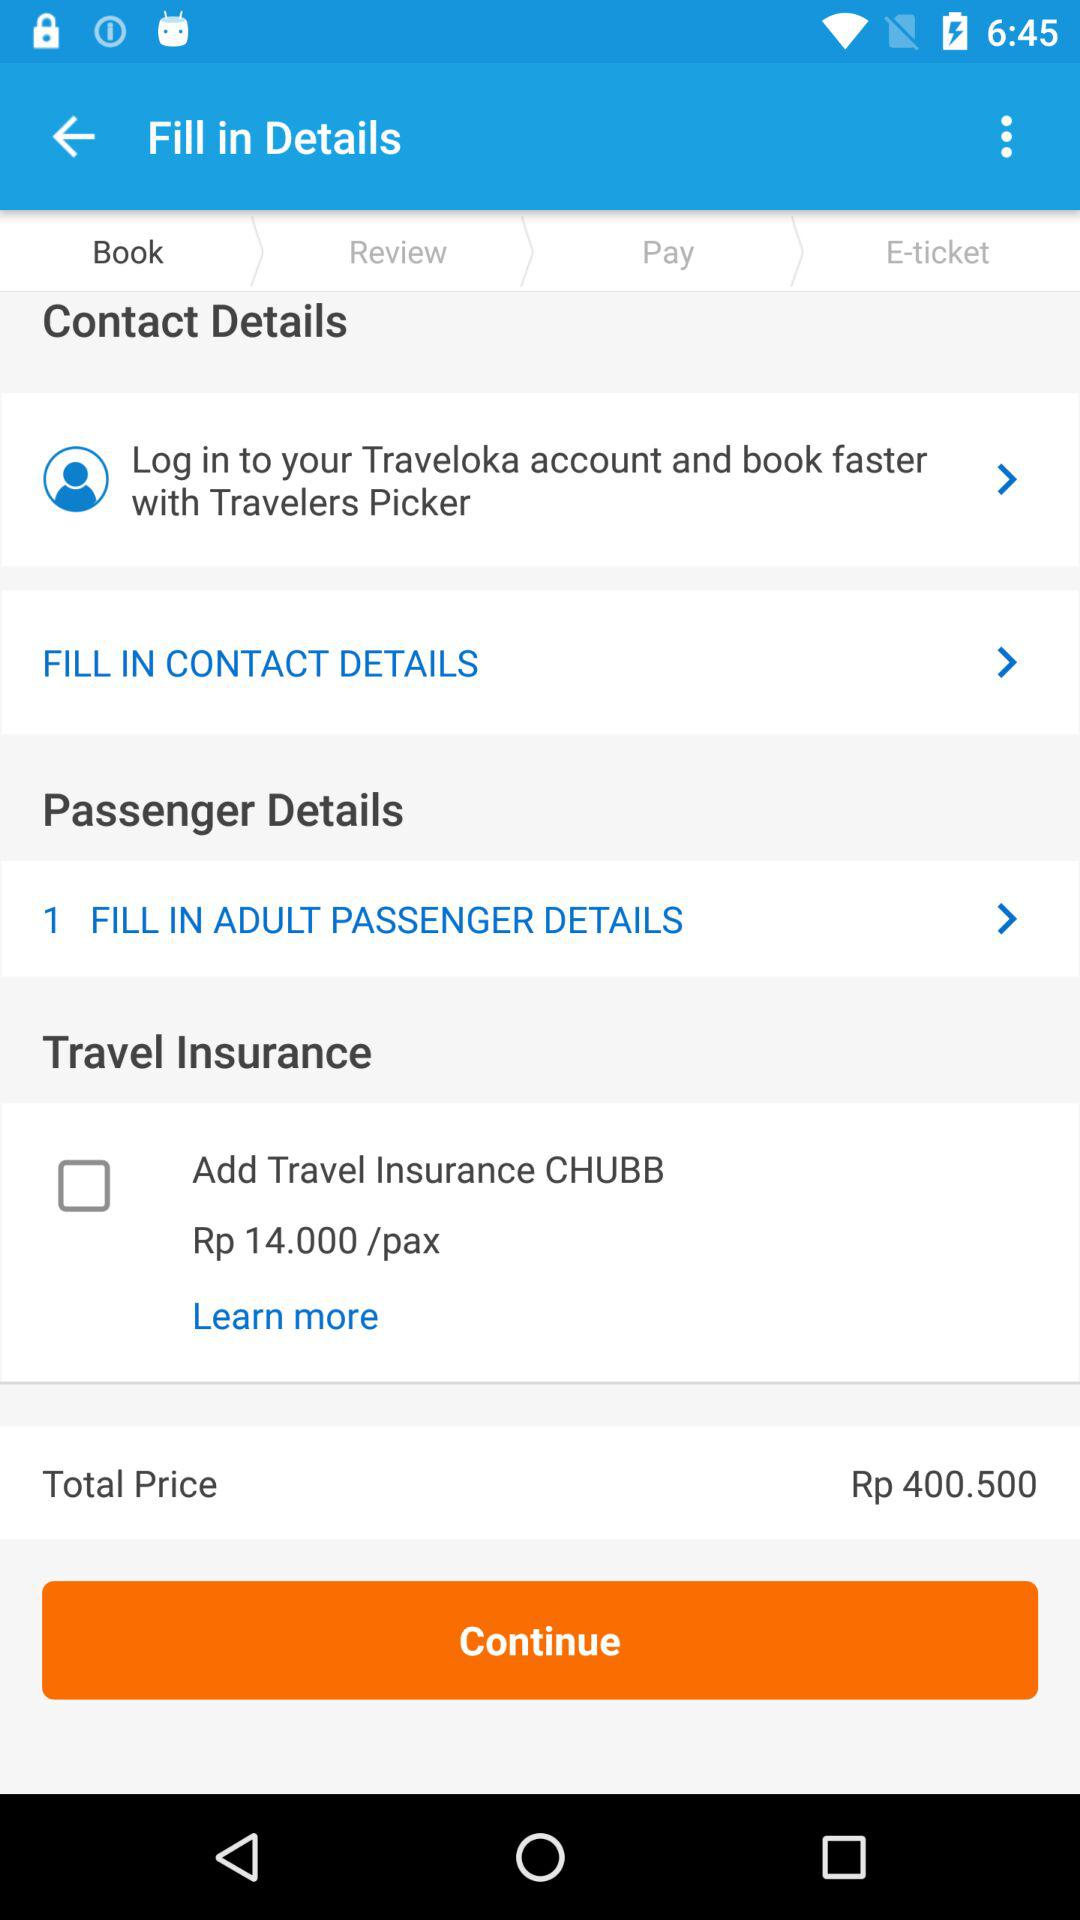How much is the total price of the booking?
Answer the question using a single word or phrase. Rp 400.50 